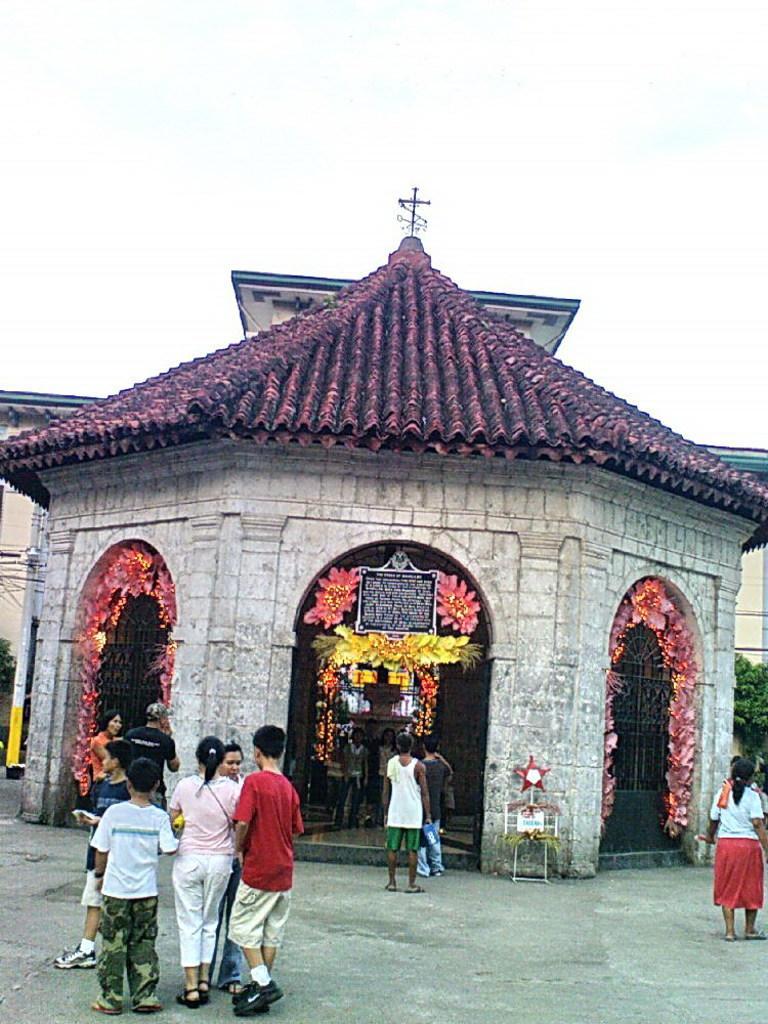Could you give a brief overview of what you see in this image? In this picture we can see group of people, in front of them we can find few buildings, flowers, trees and poles. 